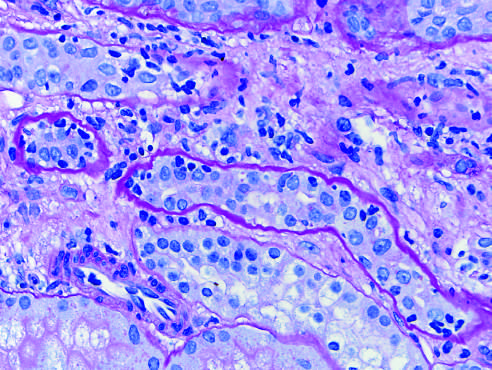s periodic acid-schiff manifested by inflammatory cells in the inter-stitium and between epithelial cells of the tubules tubulitis?
Answer the question using a single word or phrase. No 